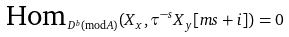<formula> <loc_0><loc_0><loc_500><loc_500>\text {Hom} _ { D ^ { b } ( \text {mod} A ) } ( X _ { x } , \tau ^ { - s } X _ { y } [ m s + i ] ) = 0</formula> 